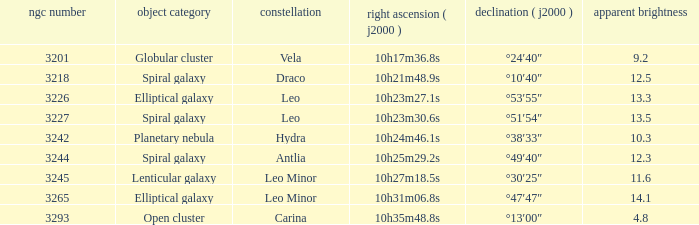What is the Apparent magnitude of a globular cluster? 9.2. 